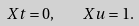<formula> <loc_0><loc_0><loc_500><loc_500>X t = 0 , \quad X u = 1 .</formula> 